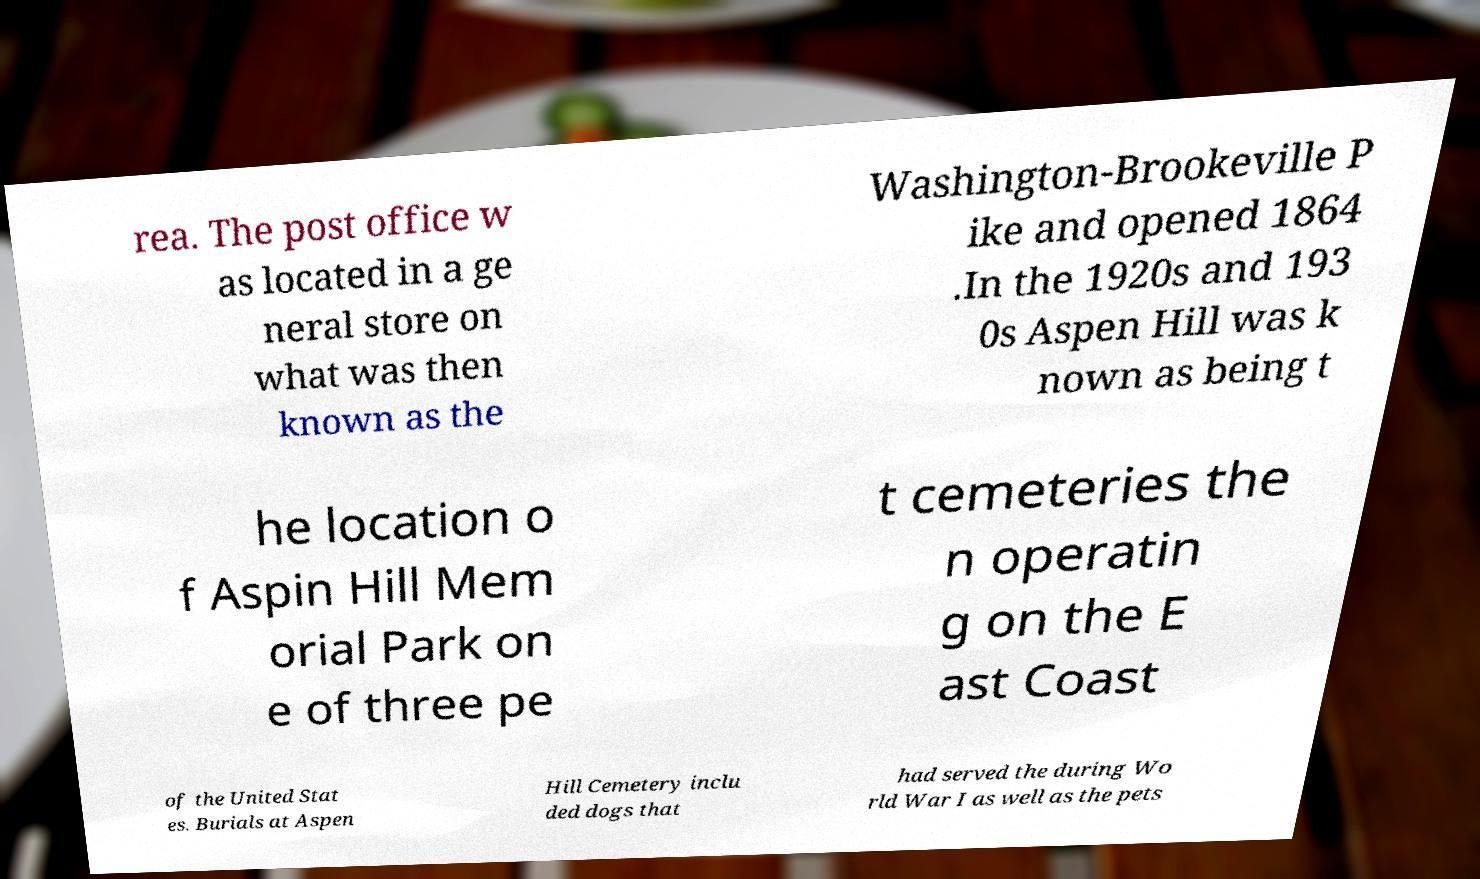Can you read and provide the text displayed in the image?This photo seems to have some interesting text. Can you extract and type it out for me? rea. The post office w as located in a ge neral store on what was then known as the Washington-Brookeville P ike and opened 1864 .In the 1920s and 193 0s Aspen Hill was k nown as being t he location o f Aspin Hill Mem orial Park on e of three pe t cemeteries the n operatin g on the E ast Coast of the United Stat es. Burials at Aspen Hill Cemetery inclu ded dogs that had served the during Wo rld War I as well as the pets 